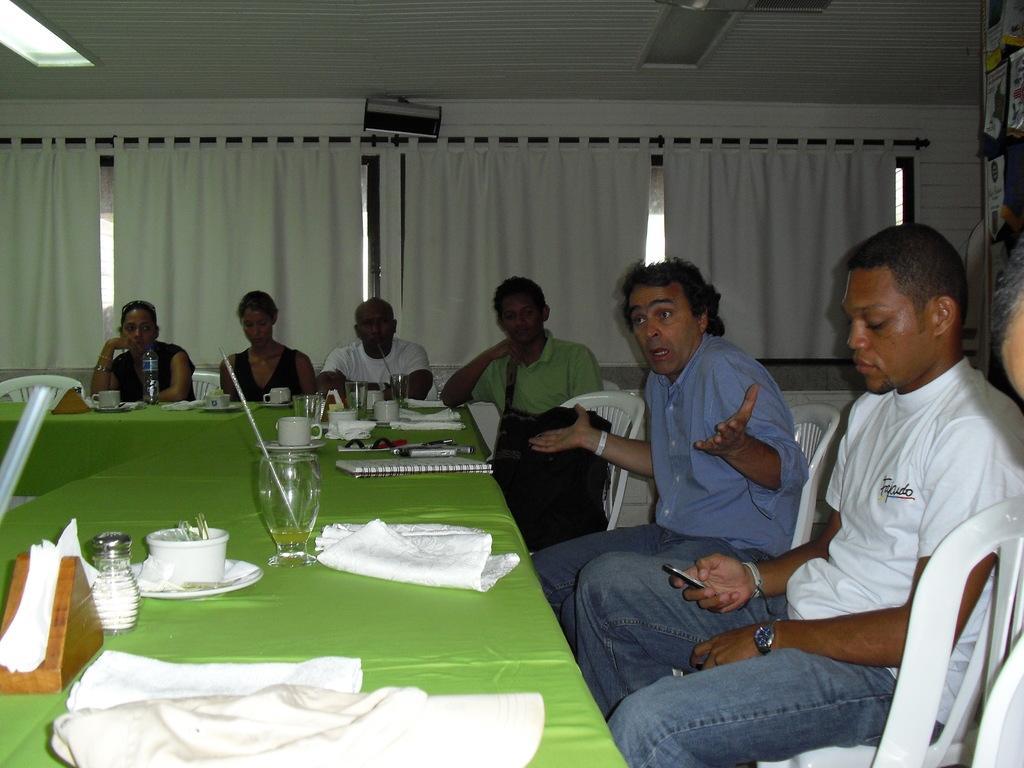Can you describe this image briefly? The picture consists of a table and people sitting beside it. On the table there is kerchief,tissue paper,cup,plate,glass,book,cloth on it. At the background there is curtain. At the there is ceiling and light. 